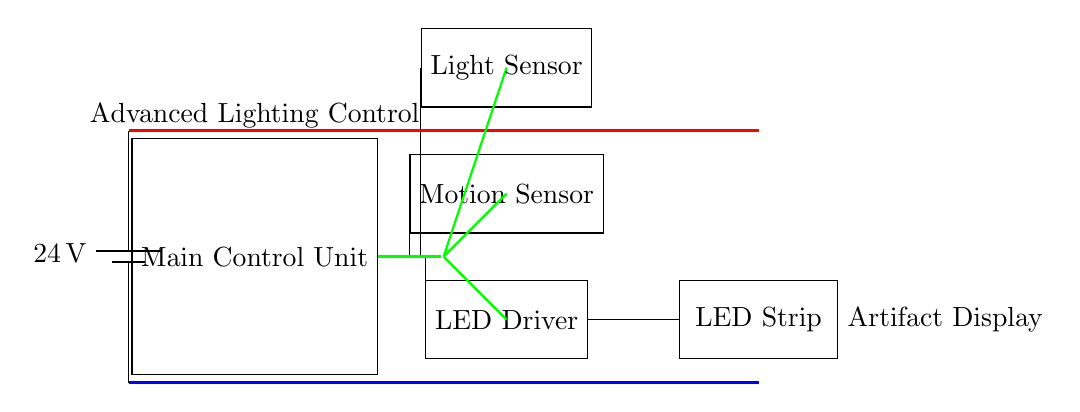What is the main voltage supplied to the circuit? The circuit is supplied with a voltage of 24 volts, as indicated by the battery symbol labeled with the value.
Answer: 24 volts What are the components connected to the Main Control Unit? The Main Control Unit is connected to the light sensor, motion sensor, and LED driver, as shown by the green signal lines branching off from the MCU.
Answer: Light sensor, motion sensor, LED driver What type of sensors are included in the circuit? The circuit includes a light sensor and a motion sensor, which are indicated by their respective labels on the diagram.
Answer: Light sensor, motion sensor Which component directly powers the LED strip? The LED driver directly powers the LED strip, as indicated in the connection from the LED driver to the LED strip.
Answer: LED driver How does the light sensor interact with the Main Control Unit? The light sensor interacts with the Main Control Unit via a green signal line, which denotes the signal flow from the sensor to the control unit for processing.
Answer: Through a signal line What is the purpose of the Main Control Unit in this circuit? The Main Control Unit serves as the central hub that processes inputs from the sensors and controls the LED driver based on those inputs to adjust lighting appropriately.
Answer: Central hub for processing inputs 